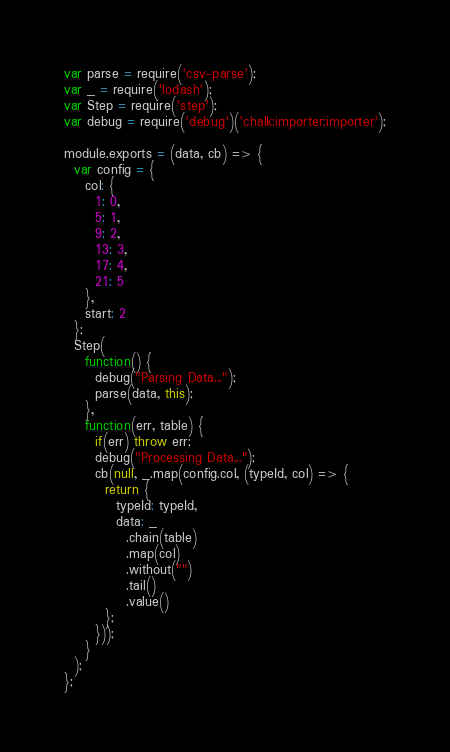<code> <loc_0><loc_0><loc_500><loc_500><_JavaScript_>var parse = require('csv-parse');
var _ = require('lodash');
var Step = require('step');
var debug = require('debug')('chalk:importer:importer');

module.exports = (data, cb) => {
  var config = {
    col: {
      1: 0,
      5: 1,
      9: 2,
      13: 3,
      17: 4,
      21: 5
    },
    start: 2
  };
  Step(
    function() {
      debug("Parsing Data...");
      parse(data, this);
    },
    function(err, table) {
      if(err) throw err;
      debug("Processing Data...");
      cb(null, _.map(config.col, (typeId, col) => {
        return {
          typeId: typeId,
          data: _
            .chain(table)
            .map(col)
            .without("")
            .tail()
            .value()
        };
      }));
    }
  );
};
</code> 